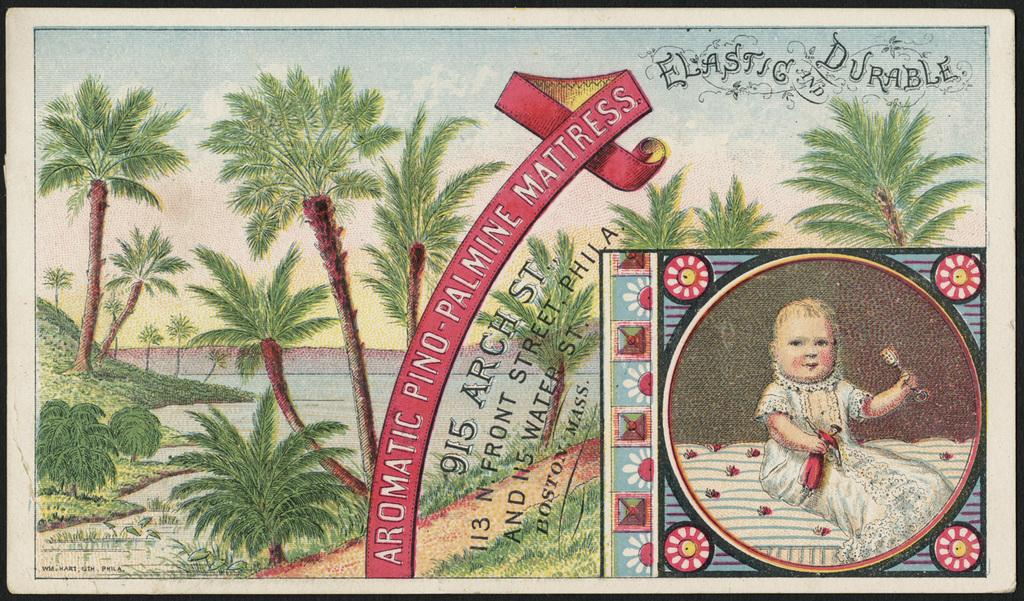What object is present in the image that typically holds a photograph? There is a photo frame in the image. What subjects are depicted in the photograph within the frame? The photograph contains images of trees, water, grass, and a baby. Is there any text present on the photo frame? Yes, there is text written on the photo frame. How many wood beetles can be seen crawling on the baby in the image? There are no wood beetles present in the image, and the baby is not shown with any insects. What type of pigs are visible in the image? There are no pigs present in the image; the photo frame contains images of trees, water, grass, and a baby. 